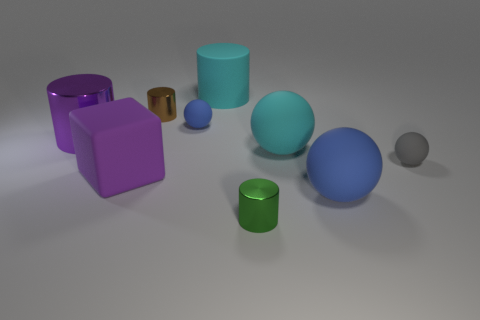What number of things have the same color as the block?
Make the answer very short. 1. What is the size of the purple thing that is the same material as the green thing?
Make the answer very short. Large. Are there any other things of the same color as the large cube?
Give a very brief answer. Yes. Is the color of the big cylinder that is on the right side of the small brown metal thing the same as the tiny rubber object behind the purple shiny cylinder?
Provide a succinct answer. No. There is a small metal thing to the left of the green cylinder; what is its color?
Your response must be concise. Brown. Does the shiny cylinder that is to the left of the purple matte thing have the same size as the gray matte ball?
Provide a short and direct response. No. Are there fewer gray rubber spheres than small yellow rubber things?
Offer a very short reply. No. The shiny thing that is the same color as the rubber cube is what shape?
Keep it short and to the point. Cylinder. There is a big cyan cylinder; what number of things are in front of it?
Your answer should be very brief. 8. Does the big purple shiny thing have the same shape as the green metal thing?
Your answer should be compact. Yes. 